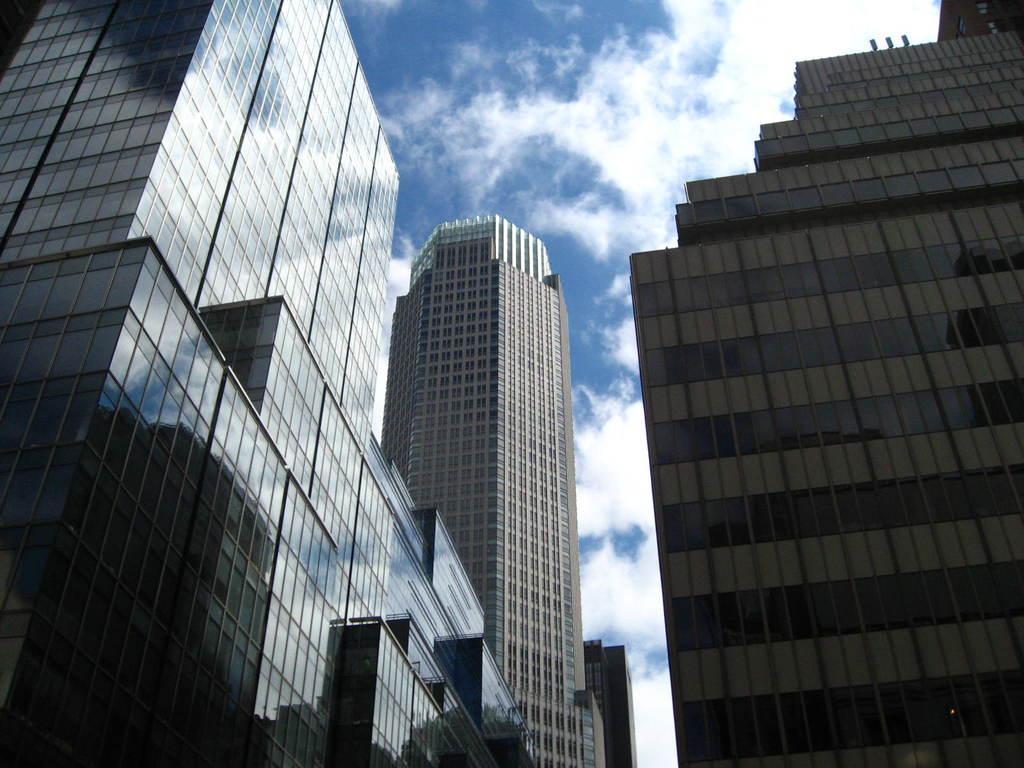Could you give a brief overview of what you see in this image? In this image I can see few buildings. In the background I can see clouds in the sky. 